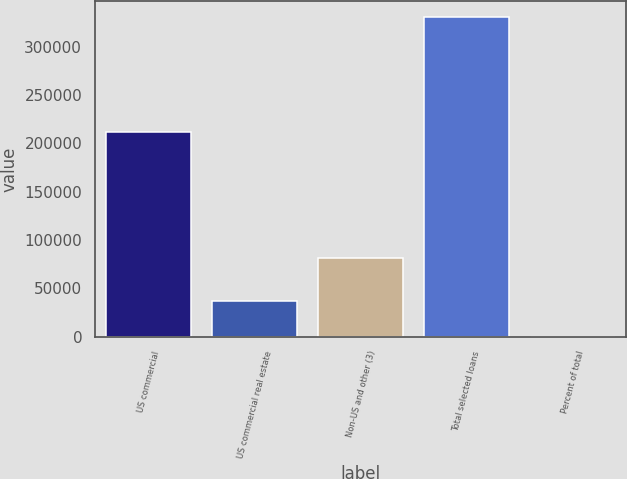Convert chart. <chart><loc_0><loc_0><loc_500><loc_500><bar_chart><fcel>US commercial<fcel>US commercial real estate<fcel>Non-US and other (3)<fcel>Total selected loans<fcel>Percent of total<nl><fcel>211969<fcel>37155<fcel>81413<fcel>330537<fcel>100<nl></chart> 